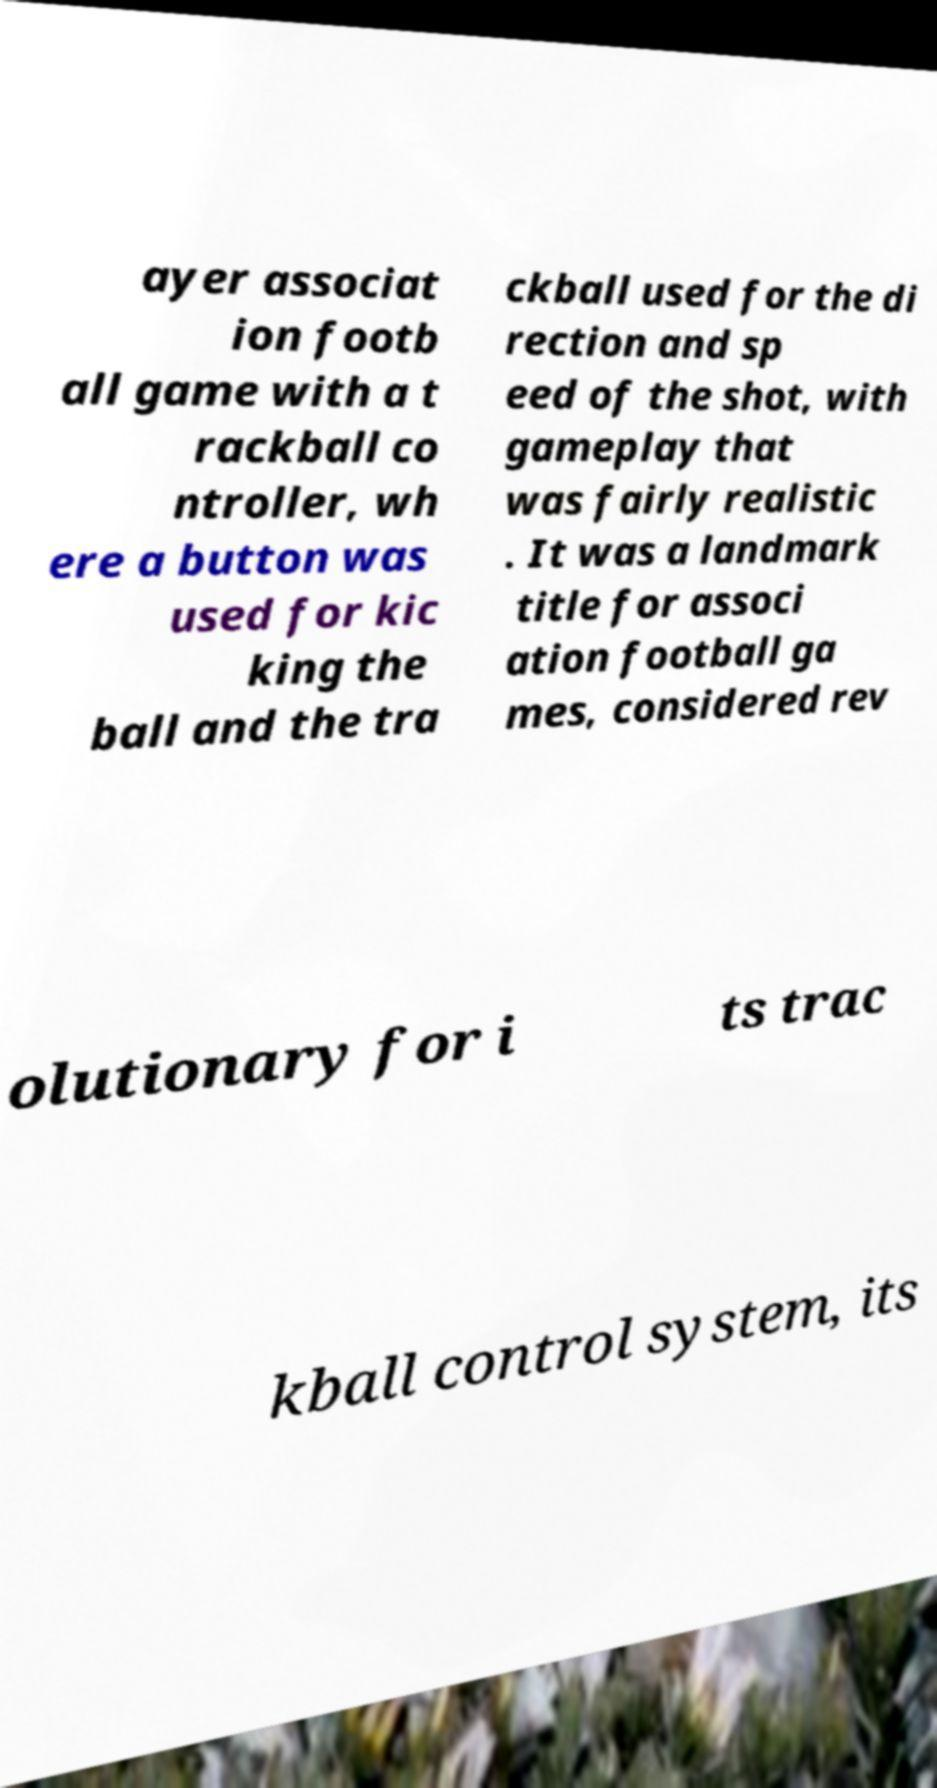Could you assist in decoding the text presented in this image and type it out clearly? ayer associat ion footb all game with a t rackball co ntroller, wh ere a button was used for kic king the ball and the tra ckball used for the di rection and sp eed of the shot, with gameplay that was fairly realistic . It was a landmark title for associ ation football ga mes, considered rev olutionary for i ts trac kball control system, its 